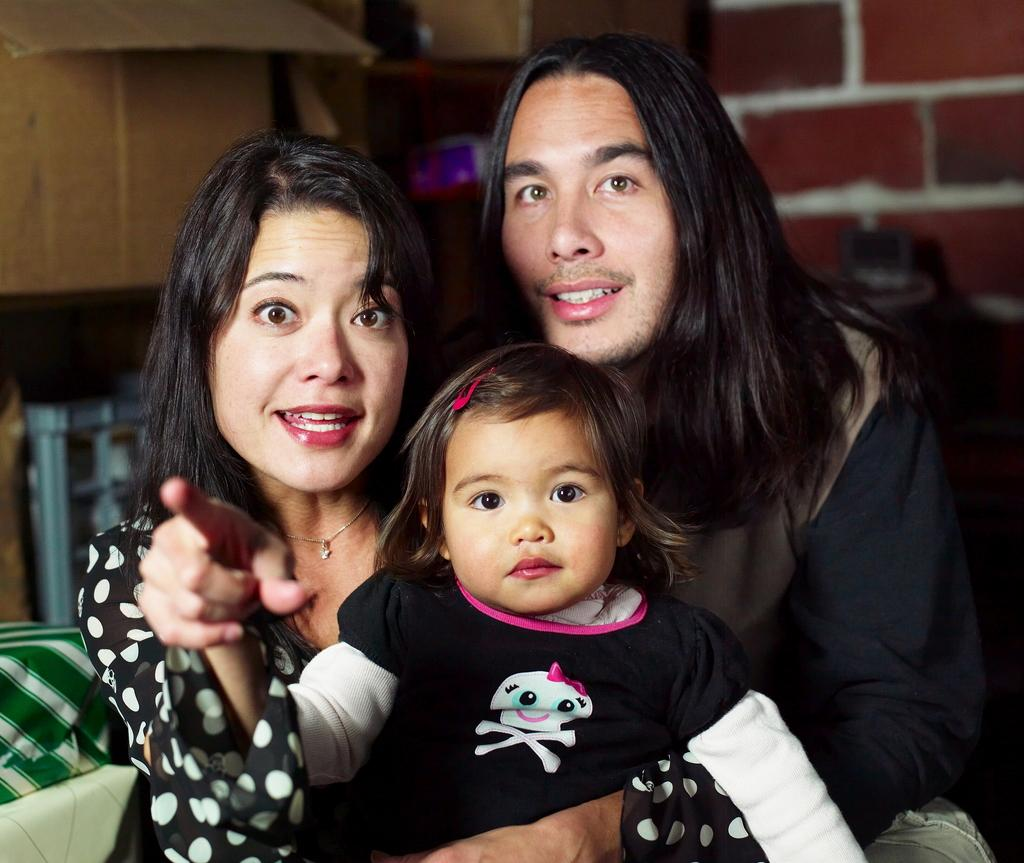How many people are in the image? There are three people in the image: a man, a woman, and a child. What are the people in the image wearing? The man, woman, and child are wearing black dresses. What can be seen in the background of the image? The background of the image is slightly blurred, and there are objects visible. What type of wall is present in the background? There is a brick wall in the background. What type of servant is present in the image? There is no servant present in the image. Is there a water source visible in the image? There is no water source visible in the image. What type of trousers is the man wearing in the image? The man is not wearing trousers; he is wearing a black dress, as mentioned in the facts. 